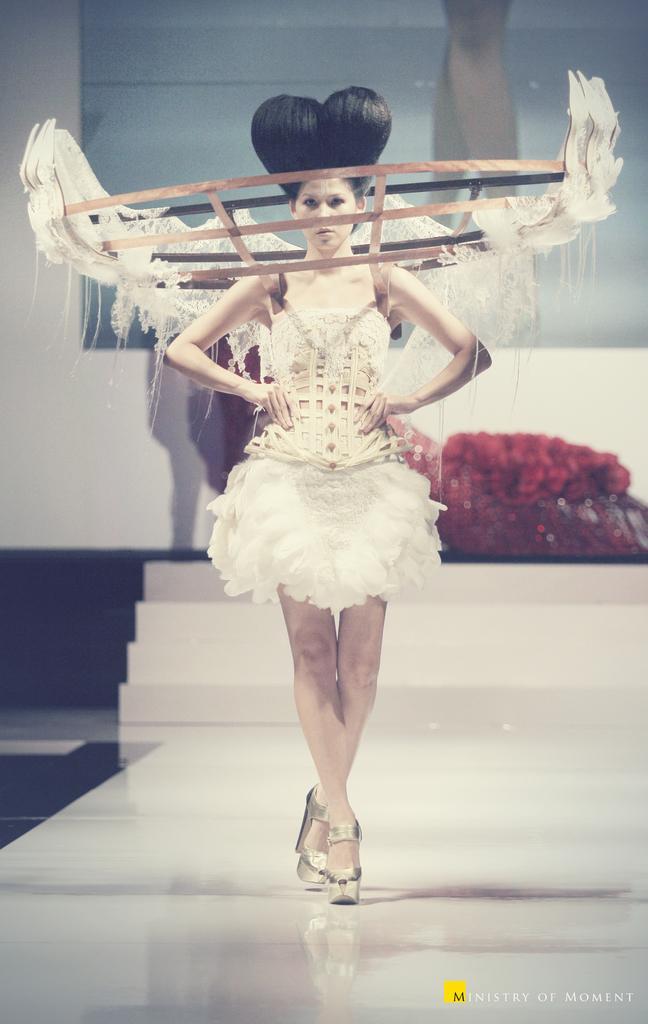In one or two sentences, can you explain what this image depicts? In this image there is a woman walking on a ramp. Behind her there are steps. In the background there is a wall. In the bottom right there is text on the image. 